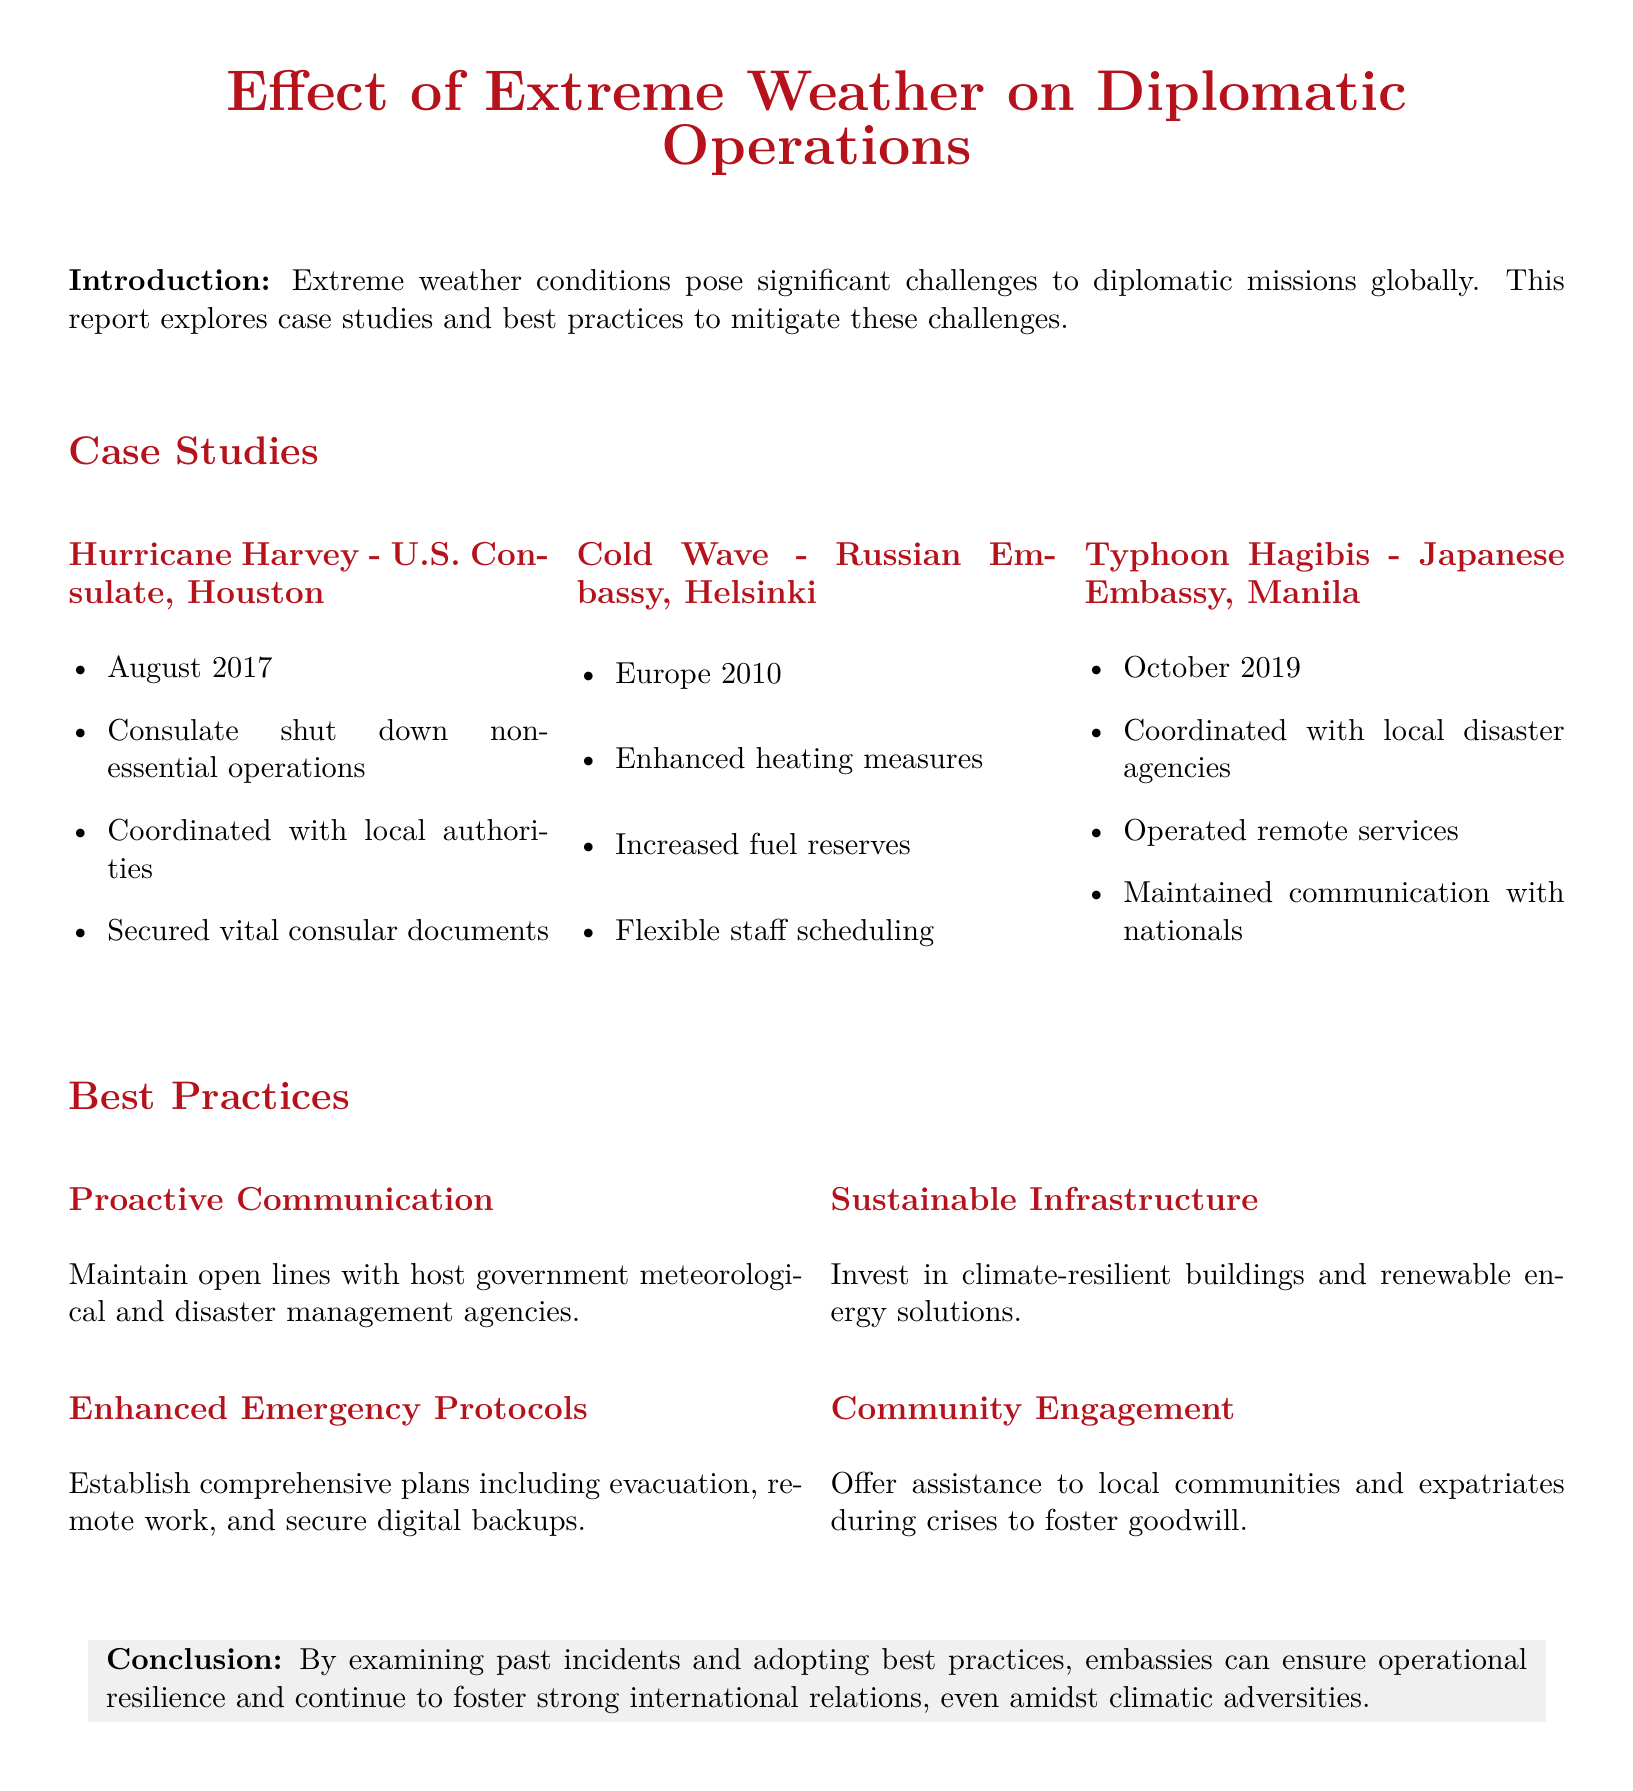What extreme weather event affected the U.S. Consulate in Houston? The document specifies that Hurricane Harvey affected the U.S. Consulate in Houston in August 2017.
Answer: Hurricane Harvey What measures were taken by the Russian Embassy in Helsinki during the cold wave? The embassy enhanced heating measures, increased fuel reserves, and implemented flexible staff scheduling.
Answer: Enhanced heating measures What did the Japanese Embassy in Manila coordinate with during Typhoon Hagibis? The document states that the Japanese Embassy coordinated with local disaster agencies during Typhoon Hagibis.
Answer: Local disaster agencies In what year did the cold wave affect the Russian Embassy in Helsinki? The report mentions that the cold wave occurred in Europe in 2010.
Answer: 2010 What type of communication is suggested as a best practice for embassies? The report recommends maintaining open lines of communication with host government meteorological and disaster management agencies.
Answer: Proactive Communication What do embassies need to establish for enhanced emergency protocols? The document highlights the need for comprehensive plans including evacuation, remote work, and secure digital backups.
Answer: Comprehensive plans What is one benefit of community engagement during crises mentioned in the document? It fosters goodwill as embassies offer assistance to local communities and expatriates during crises.
Answer: Fosters goodwill How can embassies ensure operational resilience amidst climatic adversities? By examining past incidents and adopting best practices, embassies can ensure operational resilience.
Answer: By adopting best practices 